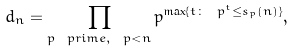Convert formula to latex. <formula><loc_0><loc_0><loc_500><loc_500>d _ { n } = \prod _ { p \ p r i m e , \ p < n } p ^ { \max \{ t \colon \ p ^ { t } \leq s _ { p } ( n ) \} } ,</formula> 